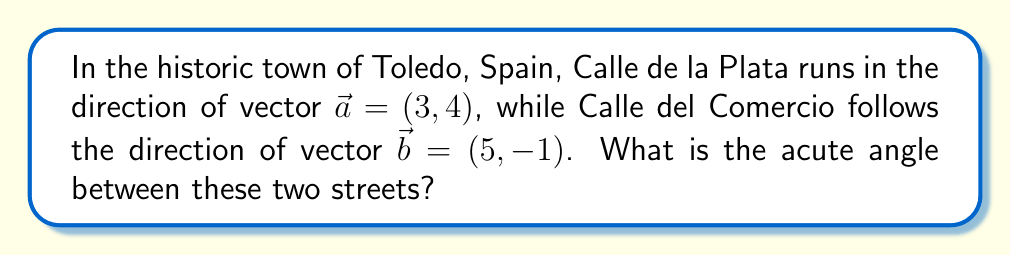Solve this math problem. To find the angle between two streets, we can use the dot product formula for vectors. The steps are as follows:

1) The dot product formula for the angle $\theta$ between two vectors $\vec{a}$ and $\vec{b}$ is:

   $$\cos \theta = \frac{\vec{a} \cdot \vec{b}}{|\vec{a}||\vec{b}|}$$

2) Calculate the dot product $\vec{a} \cdot \vec{b}$:
   $$\vec{a} \cdot \vec{b} = (3)(5) + (4)(-1) = 15 - 4 = 11$$

3) Calculate the magnitudes of the vectors:
   $$|\vec{a}| = \sqrt{3^2 + 4^2} = \sqrt{25} = 5$$
   $$|\vec{b}| = \sqrt{5^2 + (-1)^2} = \sqrt{26}$$

4) Substitute into the formula:
   $$\cos \theta = \frac{11}{5\sqrt{26}}$$

5) Take the inverse cosine (arccos) of both sides:
   $$\theta = \arccos\left(\frac{11}{5\sqrt{26}}\right)$$

6) Calculate the result:
   $$\theta \approx 0.9638 \text{ radians}$$

7) Convert to degrees:
   $$\theta \approx 55.22°$$

[asy]
import geometry;

pair A=(0,0), B=(3,4), C=(5,-1);
draw(A--B,arrow=Arrow(TeXHead));
draw(A--C,arrow=Arrow(TeXHead));
label("$\vec{a}$", B, NE);
label("$\vec{b}$", C, SE);
draw(arc(A,1,0,55.22), blue);
label("$\theta$", (0.7,0.3), blue);
[/asy]
Answer: $55.22°$ 